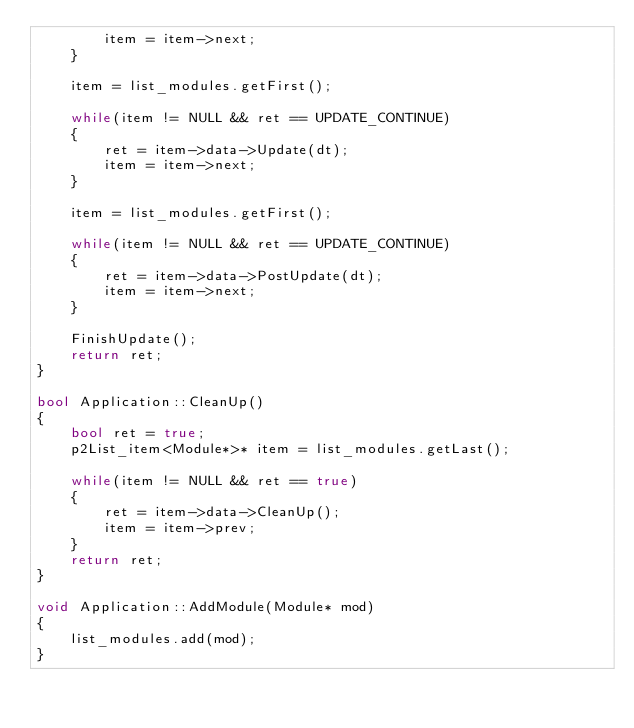<code> <loc_0><loc_0><loc_500><loc_500><_C++_>		item = item->next;
	}

	item = list_modules.getFirst();

	while(item != NULL && ret == UPDATE_CONTINUE)
	{
		ret = item->data->Update(dt);
		item = item->next;
	}

	item = list_modules.getFirst();

	while(item != NULL && ret == UPDATE_CONTINUE)
	{
		ret = item->data->PostUpdate(dt);
		item = item->next;
	}

	FinishUpdate();
	return ret;
}

bool Application::CleanUp()
{
	bool ret = true;
	p2List_item<Module*>* item = list_modules.getLast();

	while(item != NULL && ret == true)
	{
		ret = item->data->CleanUp();
		item = item->prev;
	}
	return ret;
}

void Application::AddModule(Module* mod)
{
	list_modules.add(mod);
}</code> 